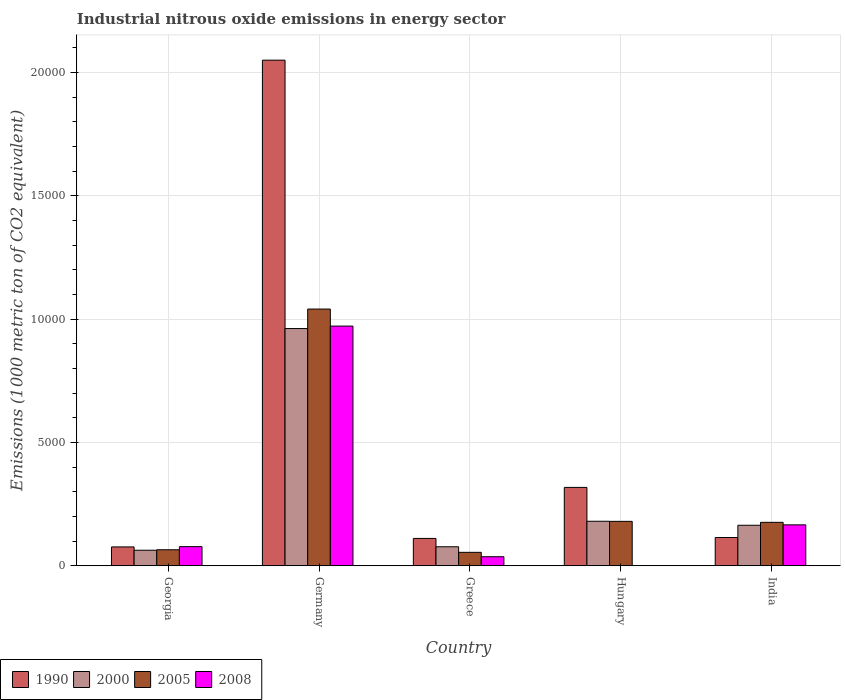Are the number of bars per tick equal to the number of legend labels?
Provide a succinct answer. Yes. How many bars are there on the 1st tick from the left?
Provide a short and direct response. 4. How many bars are there on the 3rd tick from the right?
Make the answer very short. 4. What is the amount of industrial nitrous oxide emitted in 2000 in Georgia?
Make the answer very short. 630.5. Across all countries, what is the maximum amount of industrial nitrous oxide emitted in 2005?
Ensure brevity in your answer.  1.04e+04. Across all countries, what is the minimum amount of industrial nitrous oxide emitted in 2000?
Provide a short and direct response. 630.5. In which country was the amount of industrial nitrous oxide emitted in 1990 minimum?
Offer a very short reply. Georgia. What is the total amount of industrial nitrous oxide emitted in 2005 in the graph?
Give a very brief answer. 1.52e+04. What is the difference between the amount of industrial nitrous oxide emitted in 2000 in Greece and that in Hungary?
Keep it short and to the point. -1034.4. What is the difference between the amount of industrial nitrous oxide emitted in 1990 in Germany and the amount of industrial nitrous oxide emitted in 2000 in Greece?
Your response must be concise. 1.97e+04. What is the average amount of industrial nitrous oxide emitted in 2000 per country?
Keep it short and to the point. 2893.62. What is the difference between the amount of industrial nitrous oxide emitted of/in 1990 and amount of industrial nitrous oxide emitted of/in 2008 in Greece?
Provide a succinct answer. 741.7. What is the ratio of the amount of industrial nitrous oxide emitted in 2005 in Georgia to that in Greece?
Give a very brief answer. 1.19. Is the difference between the amount of industrial nitrous oxide emitted in 1990 in Georgia and Greece greater than the difference between the amount of industrial nitrous oxide emitted in 2008 in Georgia and Greece?
Give a very brief answer. No. What is the difference between the highest and the second highest amount of industrial nitrous oxide emitted in 2005?
Give a very brief answer. 8647. What is the difference between the highest and the lowest amount of industrial nitrous oxide emitted in 1990?
Your response must be concise. 1.97e+04. In how many countries, is the amount of industrial nitrous oxide emitted in 2000 greater than the average amount of industrial nitrous oxide emitted in 2000 taken over all countries?
Provide a short and direct response. 1. Is it the case that in every country, the sum of the amount of industrial nitrous oxide emitted in 2008 and amount of industrial nitrous oxide emitted in 2005 is greater than the sum of amount of industrial nitrous oxide emitted in 2000 and amount of industrial nitrous oxide emitted in 1990?
Provide a succinct answer. No. What does the 4th bar from the left in Georgia represents?
Make the answer very short. 2008. What does the 4th bar from the right in India represents?
Offer a terse response. 1990. How many bars are there?
Make the answer very short. 20. What is the difference between two consecutive major ticks on the Y-axis?
Give a very brief answer. 5000. Are the values on the major ticks of Y-axis written in scientific E-notation?
Give a very brief answer. No. Does the graph contain grids?
Offer a terse response. Yes. Where does the legend appear in the graph?
Offer a terse response. Bottom left. How many legend labels are there?
Make the answer very short. 4. How are the legend labels stacked?
Offer a terse response. Horizontal. What is the title of the graph?
Offer a very short reply. Industrial nitrous oxide emissions in energy sector. What is the label or title of the X-axis?
Provide a succinct answer. Country. What is the label or title of the Y-axis?
Provide a short and direct response. Emissions (1000 metric ton of CO2 equivalent). What is the Emissions (1000 metric ton of CO2 equivalent) of 1990 in Georgia?
Ensure brevity in your answer.  765.3. What is the Emissions (1000 metric ton of CO2 equivalent) of 2000 in Georgia?
Make the answer very short. 630.5. What is the Emissions (1000 metric ton of CO2 equivalent) of 2005 in Georgia?
Provide a short and direct response. 650.1. What is the Emissions (1000 metric ton of CO2 equivalent) of 2008 in Georgia?
Your answer should be compact. 776.5. What is the Emissions (1000 metric ton of CO2 equivalent) in 1990 in Germany?
Your answer should be compact. 2.05e+04. What is the Emissions (1000 metric ton of CO2 equivalent) in 2000 in Germany?
Give a very brief answer. 9617.9. What is the Emissions (1000 metric ton of CO2 equivalent) in 2005 in Germany?
Ensure brevity in your answer.  1.04e+04. What is the Emissions (1000 metric ton of CO2 equivalent) in 2008 in Germany?
Provide a succinct answer. 9718.4. What is the Emissions (1000 metric ton of CO2 equivalent) of 1990 in Greece?
Your answer should be compact. 1109.1. What is the Emissions (1000 metric ton of CO2 equivalent) in 2000 in Greece?
Ensure brevity in your answer.  771. What is the Emissions (1000 metric ton of CO2 equivalent) of 2005 in Greece?
Your answer should be compact. 545.8. What is the Emissions (1000 metric ton of CO2 equivalent) of 2008 in Greece?
Your answer should be compact. 367.4. What is the Emissions (1000 metric ton of CO2 equivalent) in 1990 in Hungary?
Ensure brevity in your answer.  3178.6. What is the Emissions (1000 metric ton of CO2 equivalent) in 2000 in Hungary?
Your answer should be compact. 1805.4. What is the Emissions (1000 metric ton of CO2 equivalent) of 2005 in Hungary?
Provide a succinct answer. 1802. What is the Emissions (1000 metric ton of CO2 equivalent) of 1990 in India?
Ensure brevity in your answer.  1146.7. What is the Emissions (1000 metric ton of CO2 equivalent) of 2000 in India?
Provide a succinct answer. 1643.3. What is the Emissions (1000 metric ton of CO2 equivalent) of 2005 in India?
Offer a very short reply. 1761.9. What is the Emissions (1000 metric ton of CO2 equivalent) of 2008 in India?
Provide a succinct answer. 1659.8. Across all countries, what is the maximum Emissions (1000 metric ton of CO2 equivalent) of 1990?
Your response must be concise. 2.05e+04. Across all countries, what is the maximum Emissions (1000 metric ton of CO2 equivalent) in 2000?
Your answer should be compact. 9617.9. Across all countries, what is the maximum Emissions (1000 metric ton of CO2 equivalent) in 2005?
Give a very brief answer. 1.04e+04. Across all countries, what is the maximum Emissions (1000 metric ton of CO2 equivalent) in 2008?
Your response must be concise. 9718.4. Across all countries, what is the minimum Emissions (1000 metric ton of CO2 equivalent) in 1990?
Offer a very short reply. 765.3. Across all countries, what is the minimum Emissions (1000 metric ton of CO2 equivalent) in 2000?
Provide a succinct answer. 630.5. Across all countries, what is the minimum Emissions (1000 metric ton of CO2 equivalent) in 2005?
Provide a succinct answer. 545.8. Across all countries, what is the minimum Emissions (1000 metric ton of CO2 equivalent) in 2008?
Offer a very short reply. 6. What is the total Emissions (1000 metric ton of CO2 equivalent) of 1990 in the graph?
Your answer should be compact. 2.67e+04. What is the total Emissions (1000 metric ton of CO2 equivalent) in 2000 in the graph?
Ensure brevity in your answer.  1.45e+04. What is the total Emissions (1000 metric ton of CO2 equivalent) in 2005 in the graph?
Your answer should be very brief. 1.52e+04. What is the total Emissions (1000 metric ton of CO2 equivalent) of 2008 in the graph?
Give a very brief answer. 1.25e+04. What is the difference between the Emissions (1000 metric ton of CO2 equivalent) in 1990 in Georgia and that in Germany?
Keep it short and to the point. -1.97e+04. What is the difference between the Emissions (1000 metric ton of CO2 equivalent) in 2000 in Georgia and that in Germany?
Provide a succinct answer. -8987.4. What is the difference between the Emissions (1000 metric ton of CO2 equivalent) in 2005 in Georgia and that in Germany?
Your answer should be very brief. -9758.8. What is the difference between the Emissions (1000 metric ton of CO2 equivalent) of 2008 in Georgia and that in Germany?
Your answer should be very brief. -8941.9. What is the difference between the Emissions (1000 metric ton of CO2 equivalent) in 1990 in Georgia and that in Greece?
Your answer should be very brief. -343.8. What is the difference between the Emissions (1000 metric ton of CO2 equivalent) in 2000 in Georgia and that in Greece?
Your answer should be very brief. -140.5. What is the difference between the Emissions (1000 metric ton of CO2 equivalent) in 2005 in Georgia and that in Greece?
Offer a terse response. 104.3. What is the difference between the Emissions (1000 metric ton of CO2 equivalent) of 2008 in Georgia and that in Greece?
Ensure brevity in your answer.  409.1. What is the difference between the Emissions (1000 metric ton of CO2 equivalent) of 1990 in Georgia and that in Hungary?
Provide a short and direct response. -2413.3. What is the difference between the Emissions (1000 metric ton of CO2 equivalent) in 2000 in Georgia and that in Hungary?
Offer a very short reply. -1174.9. What is the difference between the Emissions (1000 metric ton of CO2 equivalent) of 2005 in Georgia and that in Hungary?
Ensure brevity in your answer.  -1151.9. What is the difference between the Emissions (1000 metric ton of CO2 equivalent) in 2008 in Georgia and that in Hungary?
Give a very brief answer. 770.5. What is the difference between the Emissions (1000 metric ton of CO2 equivalent) of 1990 in Georgia and that in India?
Your answer should be very brief. -381.4. What is the difference between the Emissions (1000 metric ton of CO2 equivalent) of 2000 in Georgia and that in India?
Keep it short and to the point. -1012.8. What is the difference between the Emissions (1000 metric ton of CO2 equivalent) of 2005 in Georgia and that in India?
Ensure brevity in your answer.  -1111.8. What is the difference between the Emissions (1000 metric ton of CO2 equivalent) in 2008 in Georgia and that in India?
Ensure brevity in your answer.  -883.3. What is the difference between the Emissions (1000 metric ton of CO2 equivalent) of 1990 in Germany and that in Greece?
Provide a succinct answer. 1.94e+04. What is the difference between the Emissions (1000 metric ton of CO2 equivalent) in 2000 in Germany and that in Greece?
Ensure brevity in your answer.  8846.9. What is the difference between the Emissions (1000 metric ton of CO2 equivalent) of 2005 in Germany and that in Greece?
Keep it short and to the point. 9863.1. What is the difference between the Emissions (1000 metric ton of CO2 equivalent) in 2008 in Germany and that in Greece?
Your answer should be very brief. 9351. What is the difference between the Emissions (1000 metric ton of CO2 equivalent) in 1990 in Germany and that in Hungary?
Your answer should be very brief. 1.73e+04. What is the difference between the Emissions (1000 metric ton of CO2 equivalent) in 2000 in Germany and that in Hungary?
Provide a short and direct response. 7812.5. What is the difference between the Emissions (1000 metric ton of CO2 equivalent) of 2005 in Germany and that in Hungary?
Offer a very short reply. 8606.9. What is the difference between the Emissions (1000 metric ton of CO2 equivalent) of 2008 in Germany and that in Hungary?
Offer a very short reply. 9712.4. What is the difference between the Emissions (1000 metric ton of CO2 equivalent) of 1990 in Germany and that in India?
Give a very brief answer. 1.94e+04. What is the difference between the Emissions (1000 metric ton of CO2 equivalent) of 2000 in Germany and that in India?
Ensure brevity in your answer.  7974.6. What is the difference between the Emissions (1000 metric ton of CO2 equivalent) in 2005 in Germany and that in India?
Provide a succinct answer. 8647. What is the difference between the Emissions (1000 metric ton of CO2 equivalent) of 2008 in Germany and that in India?
Give a very brief answer. 8058.6. What is the difference between the Emissions (1000 metric ton of CO2 equivalent) in 1990 in Greece and that in Hungary?
Make the answer very short. -2069.5. What is the difference between the Emissions (1000 metric ton of CO2 equivalent) of 2000 in Greece and that in Hungary?
Ensure brevity in your answer.  -1034.4. What is the difference between the Emissions (1000 metric ton of CO2 equivalent) of 2005 in Greece and that in Hungary?
Offer a very short reply. -1256.2. What is the difference between the Emissions (1000 metric ton of CO2 equivalent) in 2008 in Greece and that in Hungary?
Offer a very short reply. 361.4. What is the difference between the Emissions (1000 metric ton of CO2 equivalent) in 1990 in Greece and that in India?
Provide a succinct answer. -37.6. What is the difference between the Emissions (1000 metric ton of CO2 equivalent) of 2000 in Greece and that in India?
Give a very brief answer. -872.3. What is the difference between the Emissions (1000 metric ton of CO2 equivalent) of 2005 in Greece and that in India?
Make the answer very short. -1216.1. What is the difference between the Emissions (1000 metric ton of CO2 equivalent) in 2008 in Greece and that in India?
Your answer should be very brief. -1292.4. What is the difference between the Emissions (1000 metric ton of CO2 equivalent) of 1990 in Hungary and that in India?
Your response must be concise. 2031.9. What is the difference between the Emissions (1000 metric ton of CO2 equivalent) of 2000 in Hungary and that in India?
Your response must be concise. 162.1. What is the difference between the Emissions (1000 metric ton of CO2 equivalent) of 2005 in Hungary and that in India?
Provide a succinct answer. 40.1. What is the difference between the Emissions (1000 metric ton of CO2 equivalent) of 2008 in Hungary and that in India?
Offer a very short reply. -1653.8. What is the difference between the Emissions (1000 metric ton of CO2 equivalent) of 1990 in Georgia and the Emissions (1000 metric ton of CO2 equivalent) of 2000 in Germany?
Your response must be concise. -8852.6. What is the difference between the Emissions (1000 metric ton of CO2 equivalent) of 1990 in Georgia and the Emissions (1000 metric ton of CO2 equivalent) of 2005 in Germany?
Ensure brevity in your answer.  -9643.6. What is the difference between the Emissions (1000 metric ton of CO2 equivalent) of 1990 in Georgia and the Emissions (1000 metric ton of CO2 equivalent) of 2008 in Germany?
Your response must be concise. -8953.1. What is the difference between the Emissions (1000 metric ton of CO2 equivalent) of 2000 in Georgia and the Emissions (1000 metric ton of CO2 equivalent) of 2005 in Germany?
Ensure brevity in your answer.  -9778.4. What is the difference between the Emissions (1000 metric ton of CO2 equivalent) in 2000 in Georgia and the Emissions (1000 metric ton of CO2 equivalent) in 2008 in Germany?
Provide a short and direct response. -9087.9. What is the difference between the Emissions (1000 metric ton of CO2 equivalent) in 2005 in Georgia and the Emissions (1000 metric ton of CO2 equivalent) in 2008 in Germany?
Provide a succinct answer. -9068.3. What is the difference between the Emissions (1000 metric ton of CO2 equivalent) of 1990 in Georgia and the Emissions (1000 metric ton of CO2 equivalent) of 2000 in Greece?
Provide a short and direct response. -5.7. What is the difference between the Emissions (1000 metric ton of CO2 equivalent) of 1990 in Georgia and the Emissions (1000 metric ton of CO2 equivalent) of 2005 in Greece?
Provide a succinct answer. 219.5. What is the difference between the Emissions (1000 metric ton of CO2 equivalent) of 1990 in Georgia and the Emissions (1000 metric ton of CO2 equivalent) of 2008 in Greece?
Offer a very short reply. 397.9. What is the difference between the Emissions (1000 metric ton of CO2 equivalent) in 2000 in Georgia and the Emissions (1000 metric ton of CO2 equivalent) in 2005 in Greece?
Offer a very short reply. 84.7. What is the difference between the Emissions (1000 metric ton of CO2 equivalent) in 2000 in Georgia and the Emissions (1000 metric ton of CO2 equivalent) in 2008 in Greece?
Your response must be concise. 263.1. What is the difference between the Emissions (1000 metric ton of CO2 equivalent) in 2005 in Georgia and the Emissions (1000 metric ton of CO2 equivalent) in 2008 in Greece?
Provide a short and direct response. 282.7. What is the difference between the Emissions (1000 metric ton of CO2 equivalent) of 1990 in Georgia and the Emissions (1000 metric ton of CO2 equivalent) of 2000 in Hungary?
Provide a succinct answer. -1040.1. What is the difference between the Emissions (1000 metric ton of CO2 equivalent) in 1990 in Georgia and the Emissions (1000 metric ton of CO2 equivalent) in 2005 in Hungary?
Your response must be concise. -1036.7. What is the difference between the Emissions (1000 metric ton of CO2 equivalent) of 1990 in Georgia and the Emissions (1000 metric ton of CO2 equivalent) of 2008 in Hungary?
Give a very brief answer. 759.3. What is the difference between the Emissions (1000 metric ton of CO2 equivalent) of 2000 in Georgia and the Emissions (1000 metric ton of CO2 equivalent) of 2005 in Hungary?
Ensure brevity in your answer.  -1171.5. What is the difference between the Emissions (1000 metric ton of CO2 equivalent) in 2000 in Georgia and the Emissions (1000 metric ton of CO2 equivalent) in 2008 in Hungary?
Make the answer very short. 624.5. What is the difference between the Emissions (1000 metric ton of CO2 equivalent) in 2005 in Georgia and the Emissions (1000 metric ton of CO2 equivalent) in 2008 in Hungary?
Your answer should be compact. 644.1. What is the difference between the Emissions (1000 metric ton of CO2 equivalent) in 1990 in Georgia and the Emissions (1000 metric ton of CO2 equivalent) in 2000 in India?
Your answer should be very brief. -878. What is the difference between the Emissions (1000 metric ton of CO2 equivalent) in 1990 in Georgia and the Emissions (1000 metric ton of CO2 equivalent) in 2005 in India?
Ensure brevity in your answer.  -996.6. What is the difference between the Emissions (1000 metric ton of CO2 equivalent) in 1990 in Georgia and the Emissions (1000 metric ton of CO2 equivalent) in 2008 in India?
Provide a succinct answer. -894.5. What is the difference between the Emissions (1000 metric ton of CO2 equivalent) in 2000 in Georgia and the Emissions (1000 metric ton of CO2 equivalent) in 2005 in India?
Provide a succinct answer. -1131.4. What is the difference between the Emissions (1000 metric ton of CO2 equivalent) in 2000 in Georgia and the Emissions (1000 metric ton of CO2 equivalent) in 2008 in India?
Your response must be concise. -1029.3. What is the difference between the Emissions (1000 metric ton of CO2 equivalent) in 2005 in Georgia and the Emissions (1000 metric ton of CO2 equivalent) in 2008 in India?
Provide a succinct answer. -1009.7. What is the difference between the Emissions (1000 metric ton of CO2 equivalent) in 1990 in Germany and the Emissions (1000 metric ton of CO2 equivalent) in 2000 in Greece?
Provide a short and direct response. 1.97e+04. What is the difference between the Emissions (1000 metric ton of CO2 equivalent) of 1990 in Germany and the Emissions (1000 metric ton of CO2 equivalent) of 2005 in Greece?
Your answer should be very brief. 2.00e+04. What is the difference between the Emissions (1000 metric ton of CO2 equivalent) in 1990 in Germany and the Emissions (1000 metric ton of CO2 equivalent) in 2008 in Greece?
Make the answer very short. 2.01e+04. What is the difference between the Emissions (1000 metric ton of CO2 equivalent) of 2000 in Germany and the Emissions (1000 metric ton of CO2 equivalent) of 2005 in Greece?
Keep it short and to the point. 9072.1. What is the difference between the Emissions (1000 metric ton of CO2 equivalent) of 2000 in Germany and the Emissions (1000 metric ton of CO2 equivalent) of 2008 in Greece?
Your answer should be very brief. 9250.5. What is the difference between the Emissions (1000 metric ton of CO2 equivalent) in 2005 in Germany and the Emissions (1000 metric ton of CO2 equivalent) in 2008 in Greece?
Make the answer very short. 1.00e+04. What is the difference between the Emissions (1000 metric ton of CO2 equivalent) of 1990 in Germany and the Emissions (1000 metric ton of CO2 equivalent) of 2000 in Hungary?
Provide a succinct answer. 1.87e+04. What is the difference between the Emissions (1000 metric ton of CO2 equivalent) of 1990 in Germany and the Emissions (1000 metric ton of CO2 equivalent) of 2005 in Hungary?
Keep it short and to the point. 1.87e+04. What is the difference between the Emissions (1000 metric ton of CO2 equivalent) of 1990 in Germany and the Emissions (1000 metric ton of CO2 equivalent) of 2008 in Hungary?
Offer a terse response. 2.05e+04. What is the difference between the Emissions (1000 metric ton of CO2 equivalent) in 2000 in Germany and the Emissions (1000 metric ton of CO2 equivalent) in 2005 in Hungary?
Offer a very short reply. 7815.9. What is the difference between the Emissions (1000 metric ton of CO2 equivalent) of 2000 in Germany and the Emissions (1000 metric ton of CO2 equivalent) of 2008 in Hungary?
Your answer should be very brief. 9611.9. What is the difference between the Emissions (1000 metric ton of CO2 equivalent) in 2005 in Germany and the Emissions (1000 metric ton of CO2 equivalent) in 2008 in Hungary?
Offer a terse response. 1.04e+04. What is the difference between the Emissions (1000 metric ton of CO2 equivalent) in 1990 in Germany and the Emissions (1000 metric ton of CO2 equivalent) in 2000 in India?
Provide a short and direct response. 1.89e+04. What is the difference between the Emissions (1000 metric ton of CO2 equivalent) in 1990 in Germany and the Emissions (1000 metric ton of CO2 equivalent) in 2005 in India?
Your answer should be very brief. 1.87e+04. What is the difference between the Emissions (1000 metric ton of CO2 equivalent) in 1990 in Germany and the Emissions (1000 metric ton of CO2 equivalent) in 2008 in India?
Offer a terse response. 1.88e+04. What is the difference between the Emissions (1000 metric ton of CO2 equivalent) of 2000 in Germany and the Emissions (1000 metric ton of CO2 equivalent) of 2005 in India?
Your response must be concise. 7856. What is the difference between the Emissions (1000 metric ton of CO2 equivalent) in 2000 in Germany and the Emissions (1000 metric ton of CO2 equivalent) in 2008 in India?
Ensure brevity in your answer.  7958.1. What is the difference between the Emissions (1000 metric ton of CO2 equivalent) of 2005 in Germany and the Emissions (1000 metric ton of CO2 equivalent) of 2008 in India?
Your answer should be very brief. 8749.1. What is the difference between the Emissions (1000 metric ton of CO2 equivalent) of 1990 in Greece and the Emissions (1000 metric ton of CO2 equivalent) of 2000 in Hungary?
Keep it short and to the point. -696.3. What is the difference between the Emissions (1000 metric ton of CO2 equivalent) in 1990 in Greece and the Emissions (1000 metric ton of CO2 equivalent) in 2005 in Hungary?
Ensure brevity in your answer.  -692.9. What is the difference between the Emissions (1000 metric ton of CO2 equivalent) of 1990 in Greece and the Emissions (1000 metric ton of CO2 equivalent) of 2008 in Hungary?
Offer a terse response. 1103.1. What is the difference between the Emissions (1000 metric ton of CO2 equivalent) in 2000 in Greece and the Emissions (1000 metric ton of CO2 equivalent) in 2005 in Hungary?
Provide a succinct answer. -1031. What is the difference between the Emissions (1000 metric ton of CO2 equivalent) of 2000 in Greece and the Emissions (1000 metric ton of CO2 equivalent) of 2008 in Hungary?
Offer a terse response. 765. What is the difference between the Emissions (1000 metric ton of CO2 equivalent) in 2005 in Greece and the Emissions (1000 metric ton of CO2 equivalent) in 2008 in Hungary?
Give a very brief answer. 539.8. What is the difference between the Emissions (1000 metric ton of CO2 equivalent) of 1990 in Greece and the Emissions (1000 metric ton of CO2 equivalent) of 2000 in India?
Your answer should be compact. -534.2. What is the difference between the Emissions (1000 metric ton of CO2 equivalent) in 1990 in Greece and the Emissions (1000 metric ton of CO2 equivalent) in 2005 in India?
Provide a succinct answer. -652.8. What is the difference between the Emissions (1000 metric ton of CO2 equivalent) in 1990 in Greece and the Emissions (1000 metric ton of CO2 equivalent) in 2008 in India?
Keep it short and to the point. -550.7. What is the difference between the Emissions (1000 metric ton of CO2 equivalent) in 2000 in Greece and the Emissions (1000 metric ton of CO2 equivalent) in 2005 in India?
Your answer should be compact. -990.9. What is the difference between the Emissions (1000 metric ton of CO2 equivalent) in 2000 in Greece and the Emissions (1000 metric ton of CO2 equivalent) in 2008 in India?
Ensure brevity in your answer.  -888.8. What is the difference between the Emissions (1000 metric ton of CO2 equivalent) in 2005 in Greece and the Emissions (1000 metric ton of CO2 equivalent) in 2008 in India?
Make the answer very short. -1114. What is the difference between the Emissions (1000 metric ton of CO2 equivalent) in 1990 in Hungary and the Emissions (1000 metric ton of CO2 equivalent) in 2000 in India?
Keep it short and to the point. 1535.3. What is the difference between the Emissions (1000 metric ton of CO2 equivalent) of 1990 in Hungary and the Emissions (1000 metric ton of CO2 equivalent) of 2005 in India?
Give a very brief answer. 1416.7. What is the difference between the Emissions (1000 metric ton of CO2 equivalent) of 1990 in Hungary and the Emissions (1000 metric ton of CO2 equivalent) of 2008 in India?
Your answer should be very brief. 1518.8. What is the difference between the Emissions (1000 metric ton of CO2 equivalent) in 2000 in Hungary and the Emissions (1000 metric ton of CO2 equivalent) in 2005 in India?
Provide a short and direct response. 43.5. What is the difference between the Emissions (1000 metric ton of CO2 equivalent) in 2000 in Hungary and the Emissions (1000 metric ton of CO2 equivalent) in 2008 in India?
Provide a short and direct response. 145.6. What is the difference between the Emissions (1000 metric ton of CO2 equivalent) of 2005 in Hungary and the Emissions (1000 metric ton of CO2 equivalent) of 2008 in India?
Your response must be concise. 142.2. What is the average Emissions (1000 metric ton of CO2 equivalent) in 1990 per country?
Your answer should be very brief. 5339.86. What is the average Emissions (1000 metric ton of CO2 equivalent) of 2000 per country?
Provide a short and direct response. 2893.62. What is the average Emissions (1000 metric ton of CO2 equivalent) in 2005 per country?
Keep it short and to the point. 3033.74. What is the average Emissions (1000 metric ton of CO2 equivalent) in 2008 per country?
Make the answer very short. 2505.62. What is the difference between the Emissions (1000 metric ton of CO2 equivalent) in 1990 and Emissions (1000 metric ton of CO2 equivalent) in 2000 in Georgia?
Make the answer very short. 134.8. What is the difference between the Emissions (1000 metric ton of CO2 equivalent) in 1990 and Emissions (1000 metric ton of CO2 equivalent) in 2005 in Georgia?
Provide a short and direct response. 115.2. What is the difference between the Emissions (1000 metric ton of CO2 equivalent) in 1990 and Emissions (1000 metric ton of CO2 equivalent) in 2008 in Georgia?
Make the answer very short. -11.2. What is the difference between the Emissions (1000 metric ton of CO2 equivalent) in 2000 and Emissions (1000 metric ton of CO2 equivalent) in 2005 in Georgia?
Offer a terse response. -19.6. What is the difference between the Emissions (1000 metric ton of CO2 equivalent) in 2000 and Emissions (1000 metric ton of CO2 equivalent) in 2008 in Georgia?
Keep it short and to the point. -146. What is the difference between the Emissions (1000 metric ton of CO2 equivalent) of 2005 and Emissions (1000 metric ton of CO2 equivalent) of 2008 in Georgia?
Ensure brevity in your answer.  -126.4. What is the difference between the Emissions (1000 metric ton of CO2 equivalent) in 1990 and Emissions (1000 metric ton of CO2 equivalent) in 2000 in Germany?
Your answer should be very brief. 1.09e+04. What is the difference between the Emissions (1000 metric ton of CO2 equivalent) in 1990 and Emissions (1000 metric ton of CO2 equivalent) in 2005 in Germany?
Make the answer very short. 1.01e+04. What is the difference between the Emissions (1000 metric ton of CO2 equivalent) in 1990 and Emissions (1000 metric ton of CO2 equivalent) in 2008 in Germany?
Offer a terse response. 1.08e+04. What is the difference between the Emissions (1000 metric ton of CO2 equivalent) in 2000 and Emissions (1000 metric ton of CO2 equivalent) in 2005 in Germany?
Provide a succinct answer. -791. What is the difference between the Emissions (1000 metric ton of CO2 equivalent) in 2000 and Emissions (1000 metric ton of CO2 equivalent) in 2008 in Germany?
Give a very brief answer. -100.5. What is the difference between the Emissions (1000 metric ton of CO2 equivalent) of 2005 and Emissions (1000 metric ton of CO2 equivalent) of 2008 in Germany?
Provide a short and direct response. 690.5. What is the difference between the Emissions (1000 metric ton of CO2 equivalent) in 1990 and Emissions (1000 metric ton of CO2 equivalent) in 2000 in Greece?
Give a very brief answer. 338.1. What is the difference between the Emissions (1000 metric ton of CO2 equivalent) of 1990 and Emissions (1000 metric ton of CO2 equivalent) of 2005 in Greece?
Offer a very short reply. 563.3. What is the difference between the Emissions (1000 metric ton of CO2 equivalent) of 1990 and Emissions (1000 metric ton of CO2 equivalent) of 2008 in Greece?
Keep it short and to the point. 741.7. What is the difference between the Emissions (1000 metric ton of CO2 equivalent) in 2000 and Emissions (1000 metric ton of CO2 equivalent) in 2005 in Greece?
Ensure brevity in your answer.  225.2. What is the difference between the Emissions (1000 metric ton of CO2 equivalent) of 2000 and Emissions (1000 metric ton of CO2 equivalent) of 2008 in Greece?
Your answer should be very brief. 403.6. What is the difference between the Emissions (1000 metric ton of CO2 equivalent) in 2005 and Emissions (1000 metric ton of CO2 equivalent) in 2008 in Greece?
Provide a short and direct response. 178.4. What is the difference between the Emissions (1000 metric ton of CO2 equivalent) in 1990 and Emissions (1000 metric ton of CO2 equivalent) in 2000 in Hungary?
Ensure brevity in your answer.  1373.2. What is the difference between the Emissions (1000 metric ton of CO2 equivalent) in 1990 and Emissions (1000 metric ton of CO2 equivalent) in 2005 in Hungary?
Make the answer very short. 1376.6. What is the difference between the Emissions (1000 metric ton of CO2 equivalent) in 1990 and Emissions (1000 metric ton of CO2 equivalent) in 2008 in Hungary?
Your answer should be very brief. 3172.6. What is the difference between the Emissions (1000 metric ton of CO2 equivalent) in 2000 and Emissions (1000 metric ton of CO2 equivalent) in 2005 in Hungary?
Provide a short and direct response. 3.4. What is the difference between the Emissions (1000 metric ton of CO2 equivalent) of 2000 and Emissions (1000 metric ton of CO2 equivalent) of 2008 in Hungary?
Your answer should be compact. 1799.4. What is the difference between the Emissions (1000 metric ton of CO2 equivalent) of 2005 and Emissions (1000 metric ton of CO2 equivalent) of 2008 in Hungary?
Give a very brief answer. 1796. What is the difference between the Emissions (1000 metric ton of CO2 equivalent) in 1990 and Emissions (1000 metric ton of CO2 equivalent) in 2000 in India?
Your answer should be very brief. -496.6. What is the difference between the Emissions (1000 metric ton of CO2 equivalent) in 1990 and Emissions (1000 metric ton of CO2 equivalent) in 2005 in India?
Your response must be concise. -615.2. What is the difference between the Emissions (1000 metric ton of CO2 equivalent) of 1990 and Emissions (1000 metric ton of CO2 equivalent) of 2008 in India?
Keep it short and to the point. -513.1. What is the difference between the Emissions (1000 metric ton of CO2 equivalent) of 2000 and Emissions (1000 metric ton of CO2 equivalent) of 2005 in India?
Your answer should be very brief. -118.6. What is the difference between the Emissions (1000 metric ton of CO2 equivalent) of 2000 and Emissions (1000 metric ton of CO2 equivalent) of 2008 in India?
Your answer should be compact. -16.5. What is the difference between the Emissions (1000 metric ton of CO2 equivalent) of 2005 and Emissions (1000 metric ton of CO2 equivalent) of 2008 in India?
Keep it short and to the point. 102.1. What is the ratio of the Emissions (1000 metric ton of CO2 equivalent) of 1990 in Georgia to that in Germany?
Make the answer very short. 0.04. What is the ratio of the Emissions (1000 metric ton of CO2 equivalent) of 2000 in Georgia to that in Germany?
Your answer should be compact. 0.07. What is the ratio of the Emissions (1000 metric ton of CO2 equivalent) in 2005 in Georgia to that in Germany?
Offer a terse response. 0.06. What is the ratio of the Emissions (1000 metric ton of CO2 equivalent) in 2008 in Georgia to that in Germany?
Provide a short and direct response. 0.08. What is the ratio of the Emissions (1000 metric ton of CO2 equivalent) in 1990 in Georgia to that in Greece?
Keep it short and to the point. 0.69. What is the ratio of the Emissions (1000 metric ton of CO2 equivalent) of 2000 in Georgia to that in Greece?
Offer a terse response. 0.82. What is the ratio of the Emissions (1000 metric ton of CO2 equivalent) in 2005 in Georgia to that in Greece?
Keep it short and to the point. 1.19. What is the ratio of the Emissions (1000 metric ton of CO2 equivalent) of 2008 in Georgia to that in Greece?
Offer a very short reply. 2.11. What is the ratio of the Emissions (1000 metric ton of CO2 equivalent) in 1990 in Georgia to that in Hungary?
Your answer should be very brief. 0.24. What is the ratio of the Emissions (1000 metric ton of CO2 equivalent) of 2000 in Georgia to that in Hungary?
Ensure brevity in your answer.  0.35. What is the ratio of the Emissions (1000 metric ton of CO2 equivalent) of 2005 in Georgia to that in Hungary?
Keep it short and to the point. 0.36. What is the ratio of the Emissions (1000 metric ton of CO2 equivalent) in 2008 in Georgia to that in Hungary?
Provide a short and direct response. 129.42. What is the ratio of the Emissions (1000 metric ton of CO2 equivalent) in 1990 in Georgia to that in India?
Your answer should be compact. 0.67. What is the ratio of the Emissions (1000 metric ton of CO2 equivalent) of 2000 in Georgia to that in India?
Ensure brevity in your answer.  0.38. What is the ratio of the Emissions (1000 metric ton of CO2 equivalent) of 2005 in Georgia to that in India?
Offer a terse response. 0.37. What is the ratio of the Emissions (1000 metric ton of CO2 equivalent) in 2008 in Georgia to that in India?
Your answer should be very brief. 0.47. What is the ratio of the Emissions (1000 metric ton of CO2 equivalent) of 1990 in Germany to that in Greece?
Give a very brief answer. 18.48. What is the ratio of the Emissions (1000 metric ton of CO2 equivalent) of 2000 in Germany to that in Greece?
Give a very brief answer. 12.47. What is the ratio of the Emissions (1000 metric ton of CO2 equivalent) in 2005 in Germany to that in Greece?
Give a very brief answer. 19.07. What is the ratio of the Emissions (1000 metric ton of CO2 equivalent) of 2008 in Germany to that in Greece?
Offer a very short reply. 26.45. What is the ratio of the Emissions (1000 metric ton of CO2 equivalent) of 1990 in Germany to that in Hungary?
Provide a short and direct response. 6.45. What is the ratio of the Emissions (1000 metric ton of CO2 equivalent) of 2000 in Germany to that in Hungary?
Offer a very short reply. 5.33. What is the ratio of the Emissions (1000 metric ton of CO2 equivalent) of 2005 in Germany to that in Hungary?
Keep it short and to the point. 5.78. What is the ratio of the Emissions (1000 metric ton of CO2 equivalent) of 2008 in Germany to that in Hungary?
Keep it short and to the point. 1619.73. What is the ratio of the Emissions (1000 metric ton of CO2 equivalent) of 1990 in Germany to that in India?
Offer a very short reply. 17.88. What is the ratio of the Emissions (1000 metric ton of CO2 equivalent) in 2000 in Germany to that in India?
Offer a very short reply. 5.85. What is the ratio of the Emissions (1000 metric ton of CO2 equivalent) in 2005 in Germany to that in India?
Provide a short and direct response. 5.91. What is the ratio of the Emissions (1000 metric ton of CO2 equivalent) in 2008 in Germany to that in India?
Your response must be concise. 5.86. What is the ratio of the Emissions (1000 metric ton of CO2 equivalent) of 1990 in Greece to that in Hungary?
Your answer should be very brief. 0.35. What is the ratio of the Emissions (1000 metric ton of CO2 equivalent) in 2000 in Greece to that in Hungary?
Your answer should be compact. 0.43. What is the ratio of the Emissions (1000 metric ton of CO2 equivalent) of 2005 in Greece to that in Hungary?
Make the answer very short. 0.3. What is the ratio of the Emissions (1000 metric ton of CO2 equivalent) of 2008 in Greece to that in Hungary?
Provide a succinct answer. 61.23. What is the ratio of the Emissions (1000 metric ton of CO2 equivalent) in 1990 in Greece to that in India?
Your answer should be very brief. 0.97. What is the ratio of the Emissions (1000 metric ton of CO2 equivalent) in 2000 in Greece to that in India?
Your answer should be compact. 0.47. What is the ratio of the Emissions (1000 metric ton of CO2 equivalent) of 2005 in Greece to that in India?
Offer a terse response. 0.31. What is the ratio of the Emissions (1000 metric ton of CO2 equivalent) in 2008 in Greece to that in India?
Your response must be concise. 0.22. What is the ratio of the Emissions (1000 metric ton of CO2 equivalent) of 1990 in Hungary to that in India?
Provide a succinct answer. 2.77. What is the ratio of the Emissions (1000 metric ton of CO2 equivalent) of 2000 in Hungary to that in India?
Your answer should be very brief. 1.1. What is the ratio of the Emissions (1000 metric ton of CO2 equivalent) of 2005 in Hungary to that in India?
Provide a succinct answer. 1.02. What is the ratio of the Emissions (1000 metric ton of CO2 equivalent) in 2008 in Hungary to that in India?
Provide a short and direct response. 0. What is the difference between the highest and the second highest Emissions (1000 metric ton of CO2 equivalent) in 1990?
Offer a terse response. 1.73e+04. What is the difference between the highest and the second highest Emissions (1000 metric ton of CO2 equivalent) of 2000?
Offer a very short reply. 7812.5. What is the difference between the highest and the second highest Emissions (1000 metric ton of CO2 equivalent) of 2005?
Offer a terse response. 8606.9. What is the difference between the highest and the second highest Emissions (1000 metric ton of CO2 equivalent) in 2008?
Offer a terse response. 8058.6. What is the difference between the highest and the lowest Emissions (1000 metric ton of CO2 equivalent) in 1990?
Ensure brevity in your answer.  1.97e+04. What is the difference between the highest and the lowest Emissions (1000 metric ton of CO2 equivalent) of 2000?
Your answer should be very brief. 8987.4. What is the difference between the highest and the lowest Emissions (1000 metric ton of CO2 equivalent) in 2005?
Your answer should be very brief. 9863.1. What is the difference between the highest and the lowest Emissions (1000 metric ton of CO2 equivalent) in 2008?
Give a very brief answer. 9712.4. 